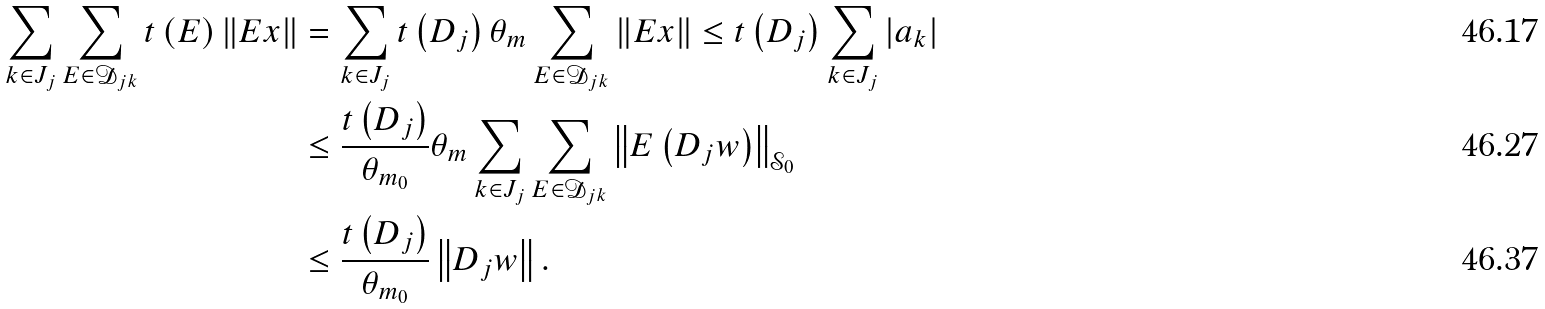<formula> <loc_0><loc_0><loc_500><loc_500>\sum _ { k \in J _ { j } } \sum _ { E \in \mathcal { D } _ { j k } } t \left ( E \right ) \left \| E x \right \| & = \sum _ { k \in J _ { j } } t \left ( D _ { j } \right ) \theta _ { m } \sum _ { E \in \mathcal { D } _ { j k } } \left \| E x \right \| \leq t \left ( D _ { j } \right ) \sum _ { k \in J _ { j } } \left | a _ { k } \right | \\ & \leq \frac { t \left ( D _ { j } \right ) } { \theta _ { m _ { 0 } } } \theta _ { m } \sum _ { k \in J _ { j } } \sum _ { E \in \mathcal { D } _ { j k } } \left \| E \left ( D _ { j } w \right ) \right \| _ { \mathcal { S } _ { 0 } } \\ & \leq \frac { t \left ( D _ { j } \right ) } { \theta _ { m _ { 0 } } } \left \| D _ { j } w \right \| .</formula> 